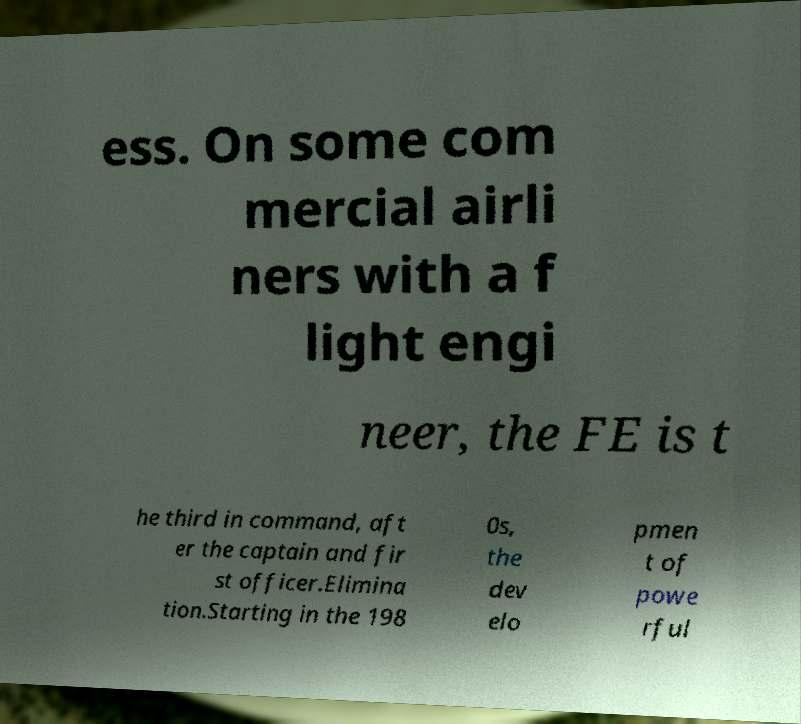Can you read and provide the text displayed in the image?This photo seems to have some interesting text. Can you extract and type it out for me? ess. On some com mercial airli ners with a f light engi neer, the FE is t he third in command, aft er the captain and fir st officer.Elimina tion.Starting in the 198 0s, the dev elo pmen t of powe rful 